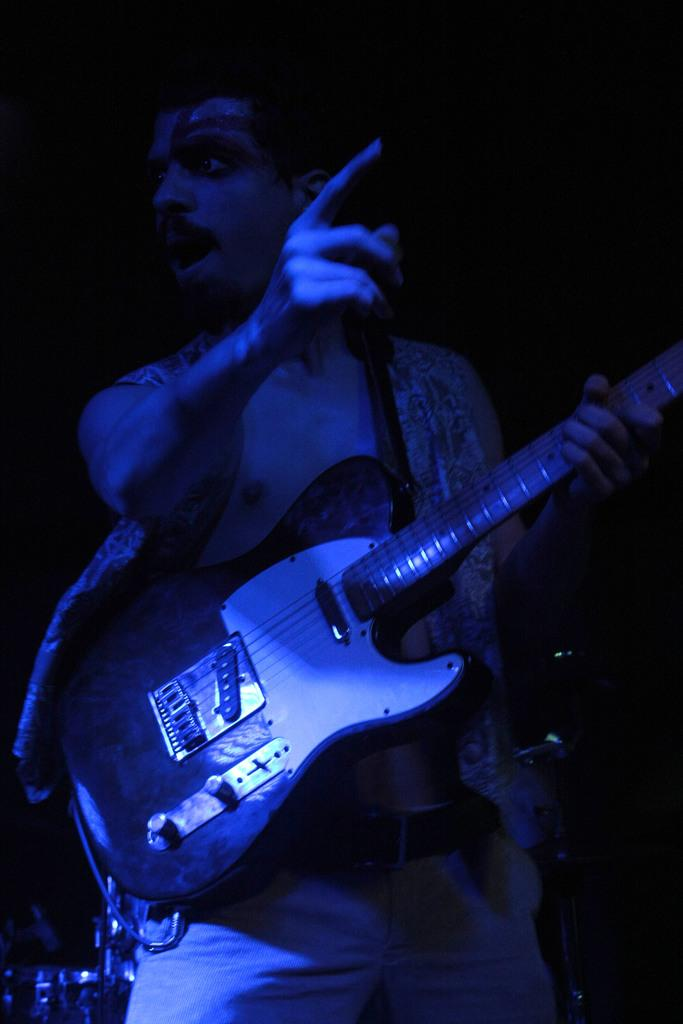What is the main subject of the image? The main subject of the image is a man. What is the man doing in the image? The man is standing in the image. What object is the man holding in the image? The man is holding a guitar in the image. What type of locket is the man wearing around his neck in the image? There is no locket visible around the man's neck in the image. What type of throne is the man sitting on in the image? The man is standing, not sitting on a throne, in the image. 